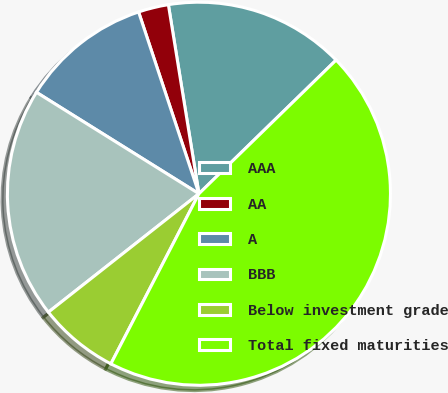Convert chart. <chart><loc_0><loc_0><loc_500><loc_500><pie_chart><fcel>AAA<fcel>AA<fcel>A<fcel>BBB<fcel>Below investment grade<fcel>Total fixed maturities<nl><fcel>15.26%<fcel>2.55%<fcel>11.02%<fcel>19.49%<fcel>6.79%<fcel>44.9%<nl></chart> 